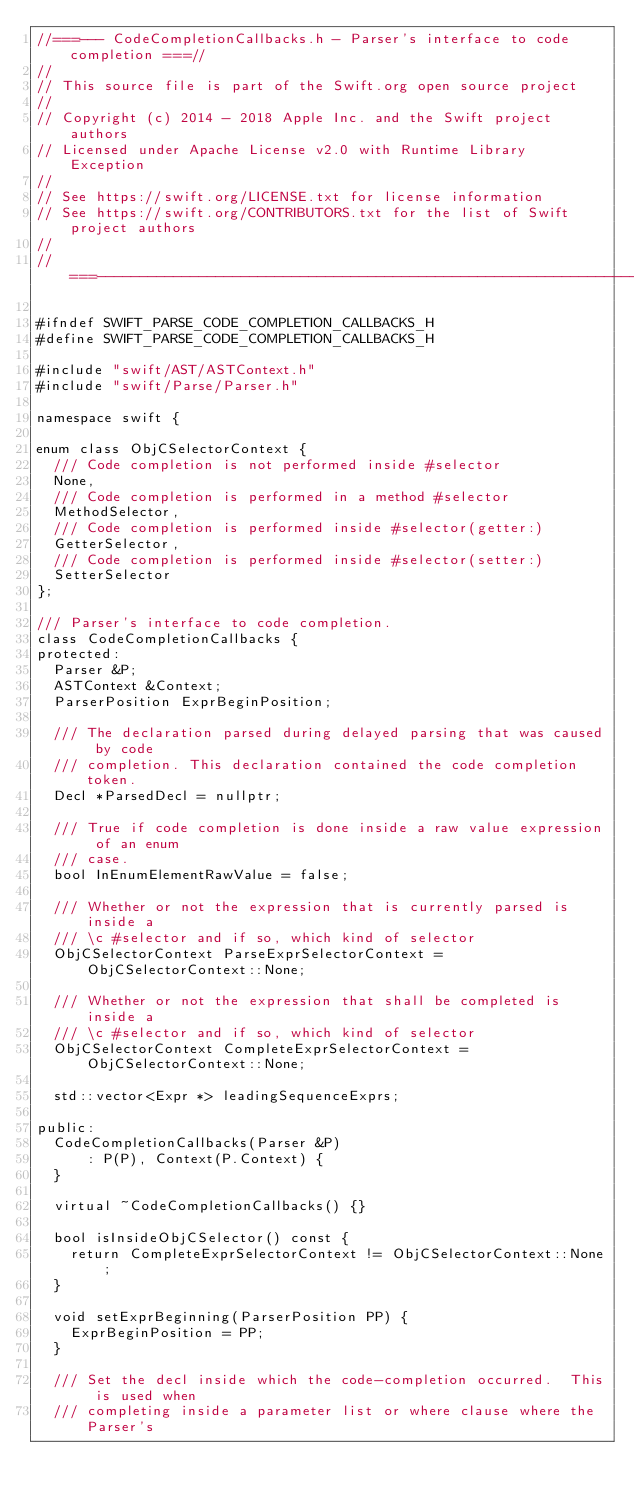Convert code to text. <code><loc_0><loc_0><loc_500><loc_500><_C_>//===--- CodeCompletionCallbacks.h - Parser's interface to code completion ===//
//
// This source file is part of the Swift.org open source project
//
// Copyright (c) 2014 - 2018 Apple Inc. and the Swift project authors
// Licensed under Apache License v2.0 with Runtime Library Exception
//
// See https://swift.org/LICENSE.txt for license information
// See https://swift.org/CONTRIBUTORS.txt for the list of Swift project authors
//
//===----------------------------------------------------------------------===//

#ifndef SWIFT_PARSE_CODE_COMPLETION_CALLBACKS_H
#define SWIFT_PARSE_CODE_COMPLETION_CALLBACKS_H

#include "swift/AST/ASTContext.h"
#include "swift/Parse/Parser.h"

namespace swift {

enum class ObjCSelectorContext {
  /// Code completion is not performed inside #selector
  None,
  /// Code completion is performed in a method #selector
  MethodSelector,
  /// Code completion is performed inside #selector(getter:)
  GetterSelector,
  /// Code completion is performed inside #selector(setter:)
  SetterSelector
};

/// Parser's interface to code completion.
class CodeCompletionCallbacks {
protected:
  Parser &P;
  ASTContext &Context;
  ParserPosition ExprBeginPosition;

  /// The declaration parsed during delayed parsing that was caused by code
  /// completion. This declaration contained the code completion token.
  Decl *ParsedDecl = nullptr;

  /// True if code completion is done inside a raw value expression of an enum
  /// case.
  bool InEnumElementRawValue = false;

  /// Whether or not the expression that is currently parsed is inside a
  /// \c #selector and if so, which kind of selector
  ObjCSelectorContext ParseExprSelectorContext = ObjCSelectorContext::None;

  /// Whether or not the expression that shall be completed is inside a
  /// \c #selector and if so, which kind of selector
  ObjCSelectorContext CompleteExprSelectorContext = ObjCSelectorContext::None;

  std::vector<Expr *> leadingSequenceExprs;

public:
  CodeCompletionCallbacks(Parser &P)
      : P(P), Context(P.Context) {
  }

  virtual ~CodeCompletionCallbacks() {}

  bool isInsideObjCSelector() const {
    return CompleteExprSelectorContext != ObjCSelectorContext::None;
  }

  void setExprBeginning(ParserPosition PP) {
    ExprBeginPosition = PP;
  }

  /// Set the decl inside which the code-completion occurred.  This is used when
  /// completing inside a parameter list or where clause where the Parser's</code> 